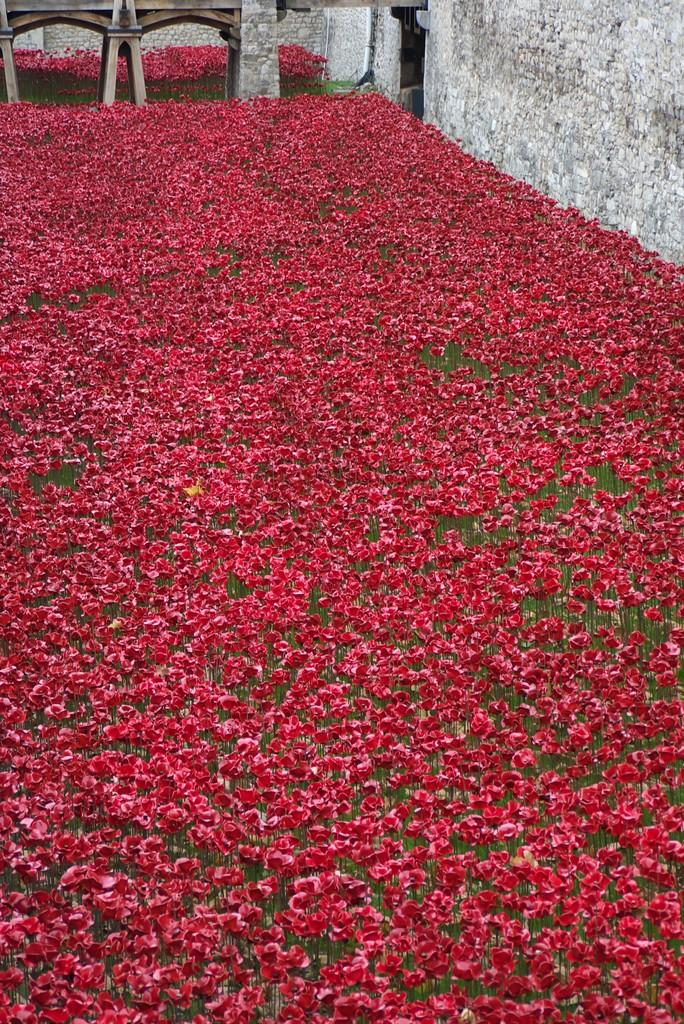What type of living organisms can be seen in the image? Plants can be seen in the image. What color are the flowers on the plants? The plants have red flowers. What is visible in the background of the image? There is a wall in the background of the image. Can you describe the object on the wall in the background? Unfortunately, the facts provided do not give any information about the object on the wall. What type of clover can be seen growing near the plants in the image? There is no mention of clover or any other type of plant growing near the plants in the image. --- Facts: 1. There is a person in the image. 2. The person is wearing a hat. 3. The person is holding a book. 4. There is a table in the image. 5. The table has a lamp on it. Absurd Topics: ocean, fish, swim Conversation: Who or what is the main subject of the image? The main subject of the image is a person. What is the person wearing in the image? The person is wearing a hat. What is the person holding in the image? The person is holding a book. What piece of furniture is present in the image? There is a table in the image. What object is on the table in the image? The table has a lamp on it. Reasoning: Let's think step by step in order to produce the conversation. We start by identifying the main subject in the image, which is the person. Then, we expand the conversation to include the person's attire and what they are holding. Next, we describe the furniture present in the image, which is a table. Finally, we mention the object on the table, which is a lamp. Absurd Question/Answer: Can you see any fish swimming in the ocean in the image? There is no mention of an ocean or fish in the image. 